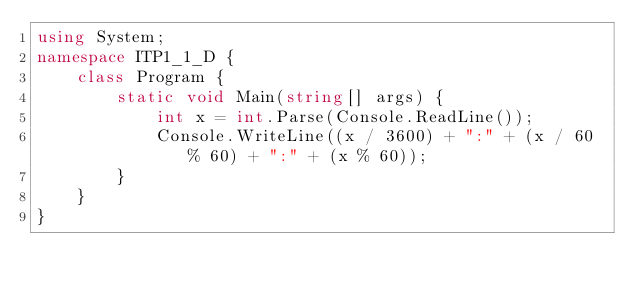<code> <loc_0><loc_0><loc_500><loc_500><_C#_>using System;
namespace ITP1_1_D {
	class Program {
		static void Main(string[] args) {
			int x = int.Parse(Console.ReadLine());
			Console.WriteLine((x / 3600) + ":" + (x / 60 % 60) + ":" + (x % 60));
		}
	}
}</code> 